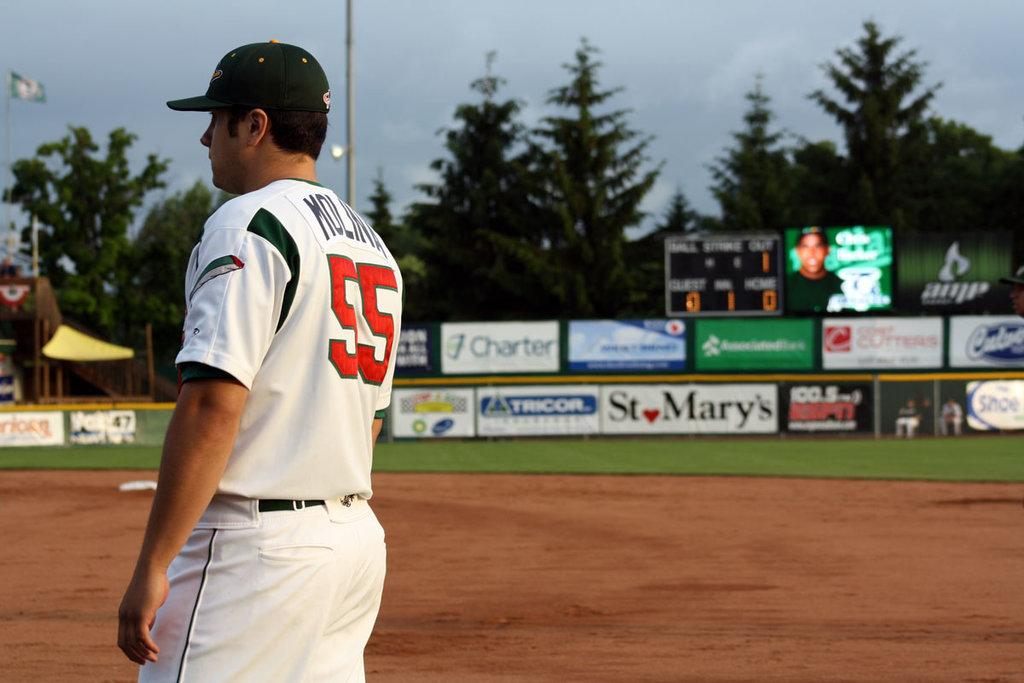<image>
Present a compact description of the photo's key features. A baseball player is standing on the field and a sign behind him says St Mary's. 